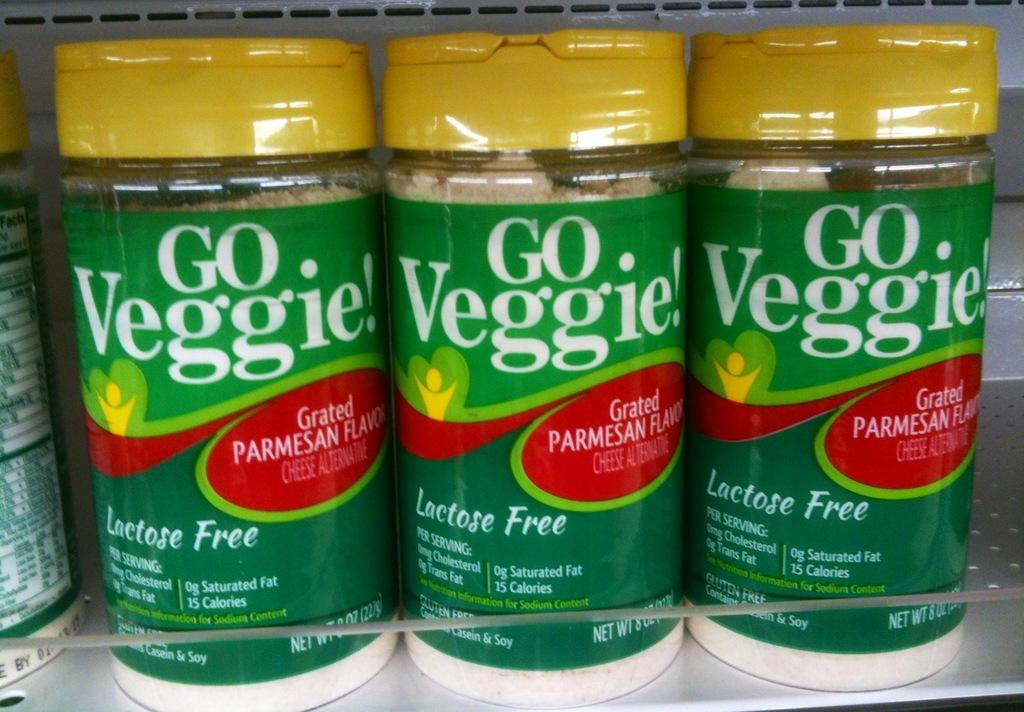<image>
Describe the image concisely. Several bottles of Go Veggie Grated Parmesan Flavored Cheese Alternative sit on a shelf. 